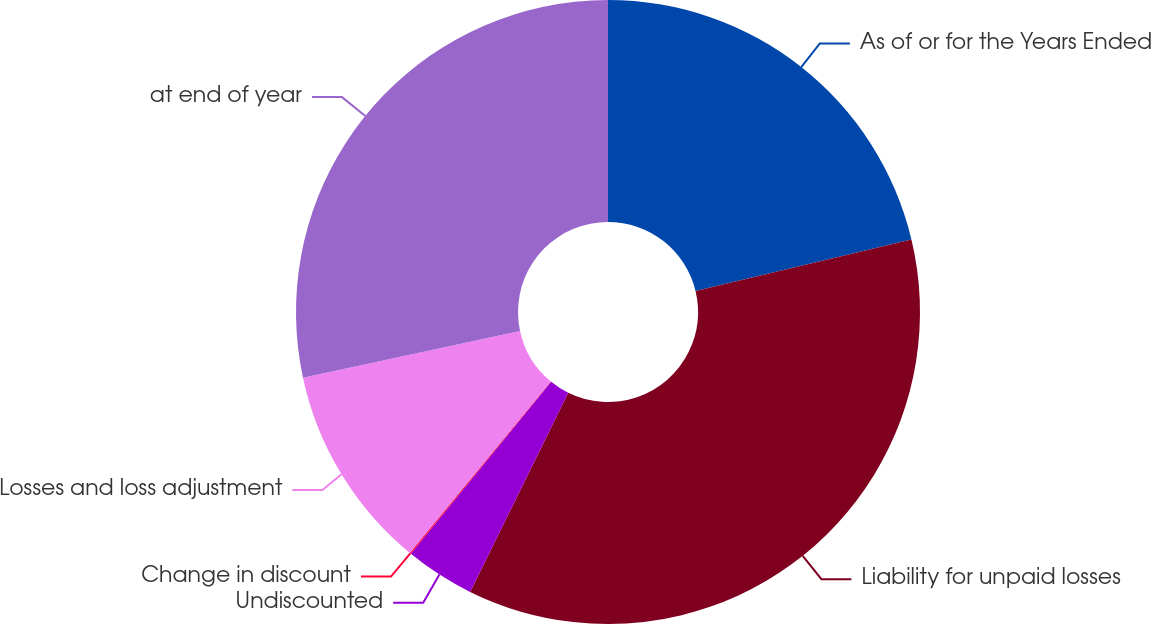Convert chart. <chart><loc_0><loc_0><loc_500><loc_500><pie_chart><fcel>As of or for the Years Ended<fcel>Liability for unpaid losses<fcel>Undiscounted<fcel>Change in discount<fcel>Losses and loss adjustment<fcel>at end of year<nl><fcel>21.26%<fcel>36.02%<fcel>3.6%<fcel>0.07%<fcel>10.67%<fcel>28.37%<nl></chart> 